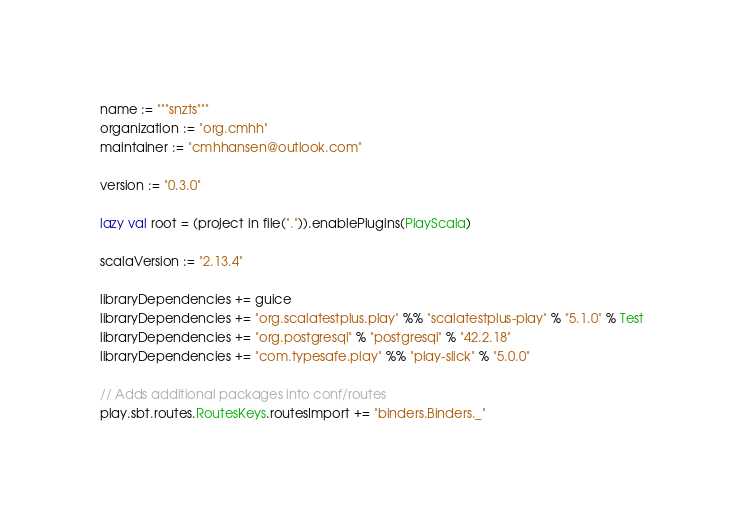Convert code to text. <code><loc_0><loc_0><loc_500><loc_500><_Scala_>name := """snzts"""
organization := "org.cmhh"
maintainer := "cmhhansen@outlook.com"

version := "0.3.0"

lazy val root = (project in file(".")).enablePlugins(PlayScala)

scalaVersion := "2.13.4"

libraryDependencies += guice
libraryDependencies += "org.scalatestplus.play" %% "scalatestplus-play" % "5.1.0" % Test
libraryDependencies += "org.postgresql" % "postgresql" % "42.2.18"
libraryDependencies += "com.typesafe.play" %% "play-slick" % "5.0.0"

// Adds additional packages into conf/routes
play.sbt.routes.RoutesKeys.routesImport += "binders.Binders._"
</code> 